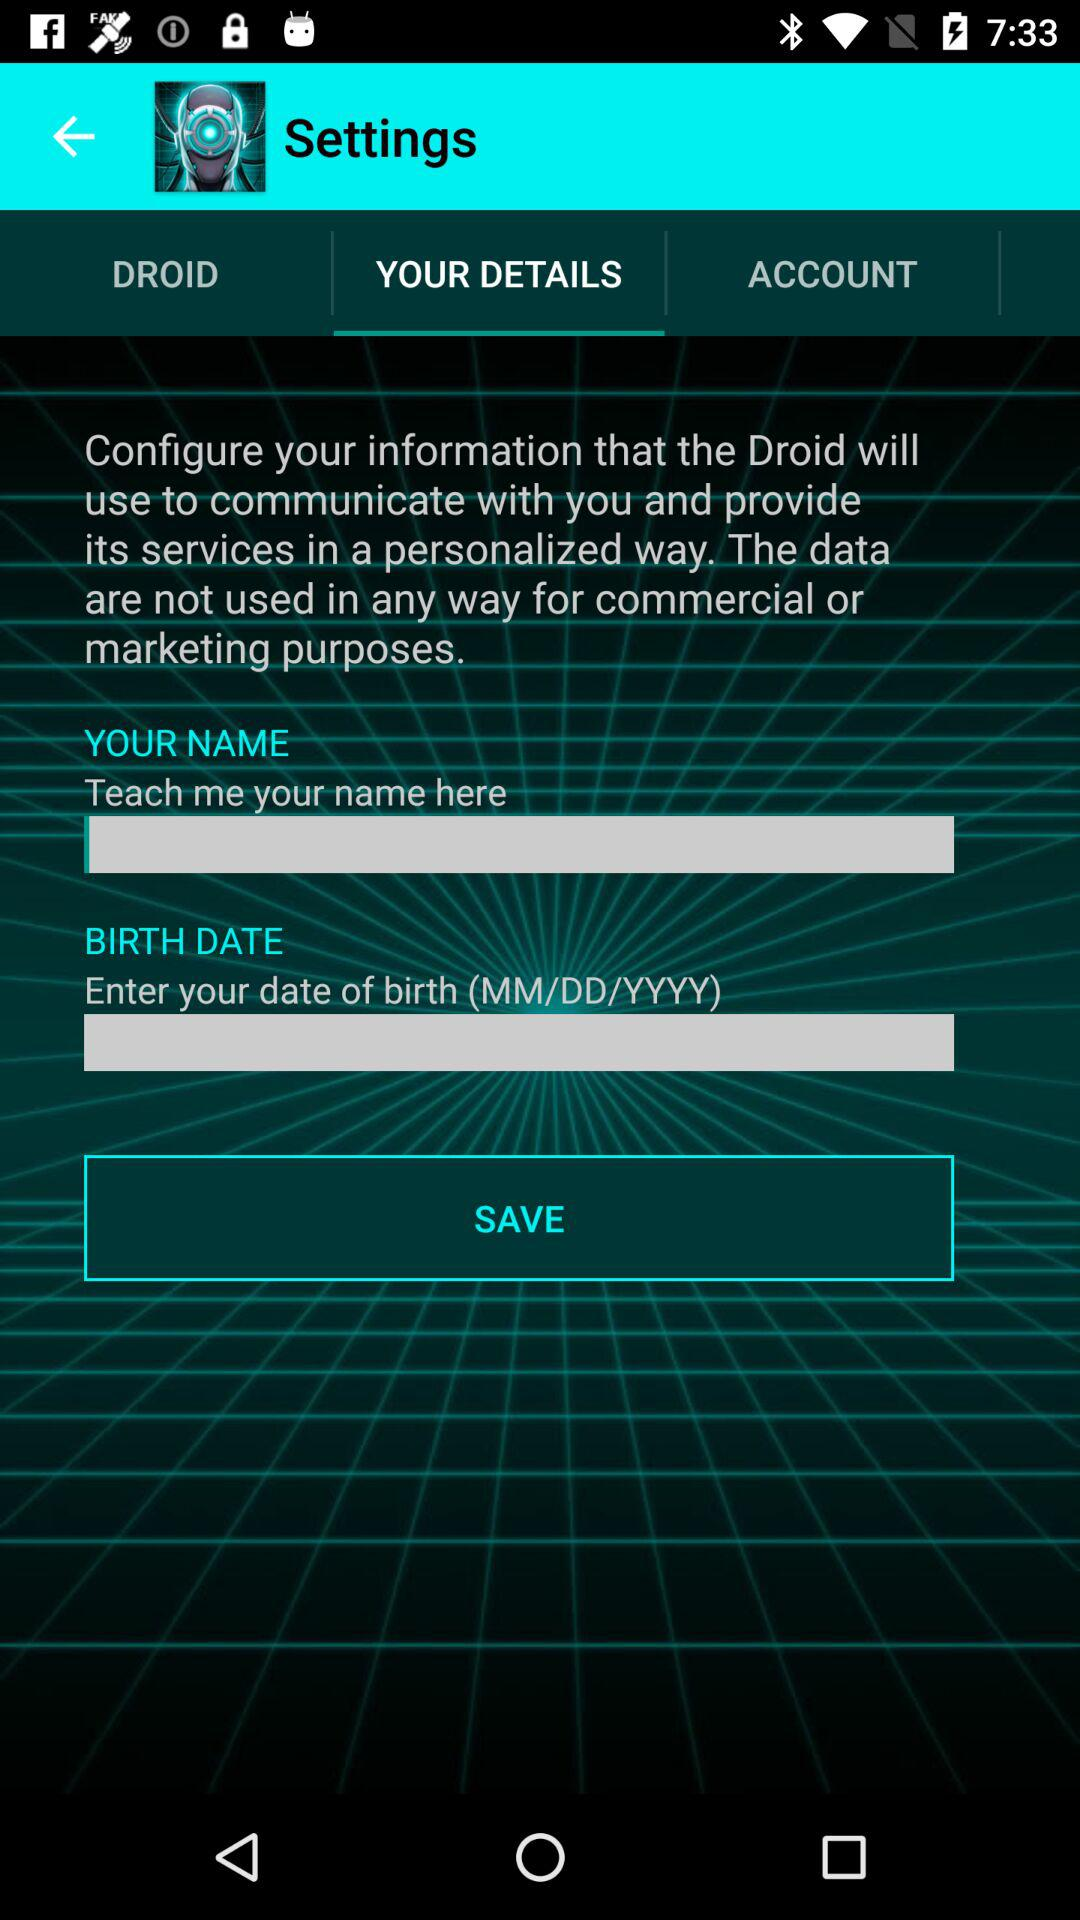Which tab is selected? The selected tab is "YOUR DETAILS". 